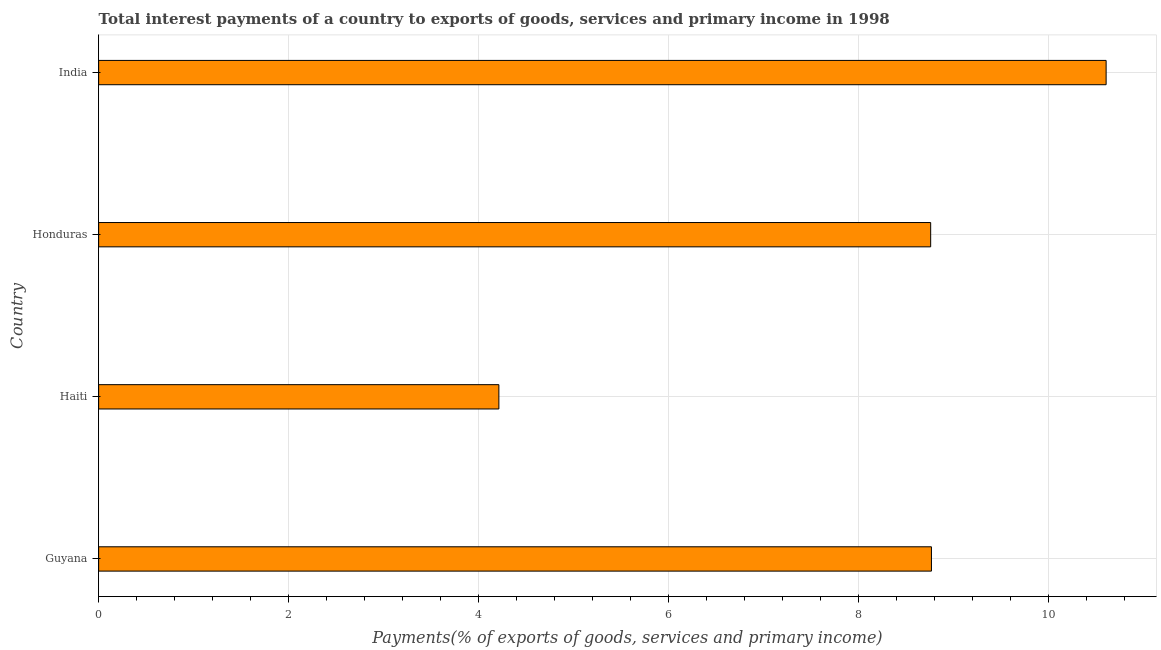Does the graph contain grids?
Provide a succinct answer. Yes. What is the title of the graph?
Your answer should be very brief. Total interest payments of a country to exports of goods, services and primary income in 1998. What is the label or title of the X-axis?
Give a very brief answer. Payments(% of exports of goods, services and primary income). What is the label or title of the Y-axis?
Offer a terse response. Country. What is the total interest payments on external debt in Haiti?
Give a very brief answer. 4.21. Across all countries, what is the maximum total interest payments on external debt?
Provide a short and direct response. 10.61. Across all countries, what is the minimum total interest payments on external debt?
Your answer should be very brief. 4.21. In which country was the total interest payments on external debt minimum?
Keep it short and to the point. Haiti. What is the sum of the total interest payments on external debt?
Keep it short and to the point. 32.35. What is the difference between the total interest payments on external debt in Guyana and Honduras?
Offer a terse response. 0.01. What is the average total interest payments on external debt per country?
Make the answer very short. 8.09. What is the median total interest payments on external debt?
Your response must be concise. 8.76. In how many countries, is the total interest payments on external debt greater than 10.4 %?
Your answer should be compact. 1. What is the ratio of the total interest payments on external debt in Guyana to that in Haiti?
Keep it short and to the point. 2.08. Is the difference between the total interest payments on external debt in Haiti and India greater than the difference between any two countries?
Provide a succinct answer. Yes. What is the difference between the highest and the second highest total interest payments on external debt?
Offer a very short reply. 1.84. Is the sum of the total interest payments on external debt in Honduras and India greater than the maximum total interest payments on external debt across all countries?
Your response must be concise. Yes. What is the difference between the highest and the lowest total interest payments on external debt?
Offer a very short reply. 6.39. How many bars are there?
Make the answer very short. 4. What is the difference between two consecutive major ticks on the X-axis?
Offer a very short reply. 2. Are the values on the major ticks of X-axis written in scientific E-notation?
Provide a succinct answer. No. What is the Payments(% of exports of goods, services and primary income) in Guyana?
Give a very brief answer. 8.77. What is the Payments(% of exports of goods, services and primary income) of Haiti?
Your answer should be very brief. 4.21. What is the Payments(% of exports of goods, services and primary income) in Honduras?
Provide a succinct answer. 8.76. What is the Payments(% of exports of goods, services and primary income) of India?
Your answer should be compact. 10.61. What is the difference between the Payments(% of exports of goods, services and primary income) in Guyana and Haiti?
Provide a succinct answer. 4.55. What is the difference between the Payments(% of exports of goods, services and primary income) in Guyana and Honduras?
Your response must be concise. 0.01. What is the difference between the Payments(% of exports of goods, services and primary income) in Guyana and India?
Offer a terse response. -1.84. What is the difference between the Payments(% of exports of goods, services and primary income) in Haiti and Honduras?
Your answer should be compact. -4.55. What is the difference between the Payments(% of exports of goods, services and primary income) in Haiti and India?
Keep it short and to the point. -6.39. What is the difference between the Payments(% of exports of goods, services and primary income) in Honduras and India?
Offer a terse response. -1.85. What is the ratio of the Payments(% of exports of goods, services and primary income) in Guyana to that in Haiti?
Make the answer very short. 2.08. What is the ratio of the Payments(% of exports of goods, services and primary income) in Guyana to that in India?
Ensure brevity in your answer.  0.83. What is the ratio of the Payments(% of exports of goods, services and primary income) in Haiti to that in Honduras?
Make the answer very short. 0.48. What is the ratio of the Payments(% of exports of goods, services and primary income) in Haiti to that in India?
Your answer should be compact. 0.4. What is the ratio of the Payments(% of exports of goods, services and primary income) in Honduras to that in India?
Provide a short and direct response. 0.83. 